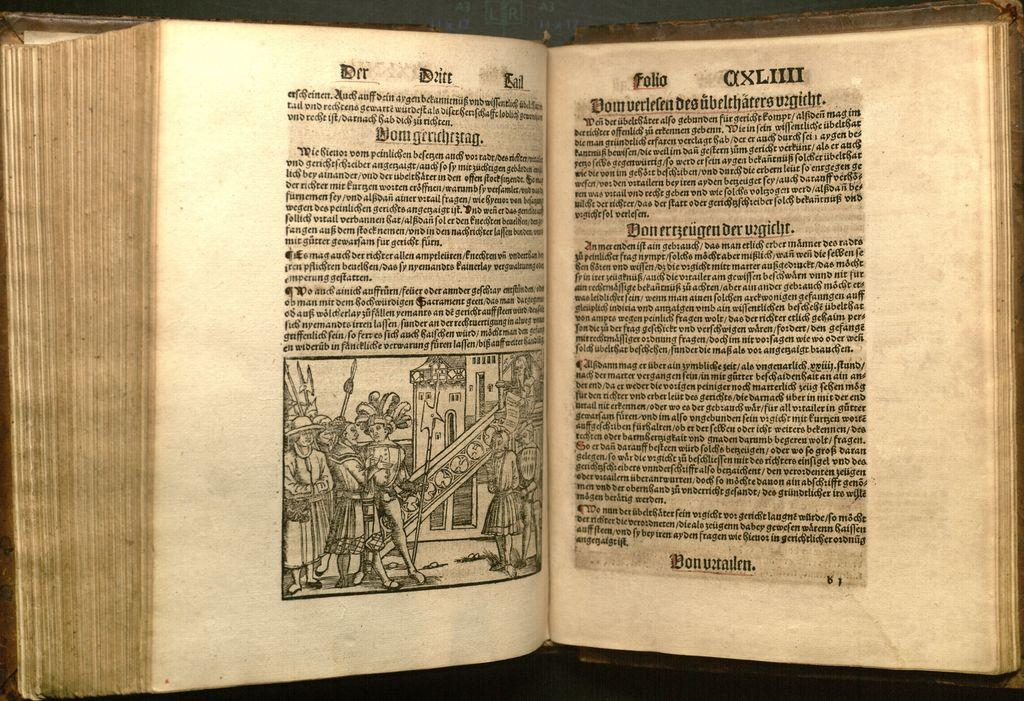<image>
Offer a succinct explanation of the picture presented. A German book with an image showing medieval related subject. 